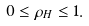<formula> <loc_0><loc_0><loc_500><loc_500>0 \leq \rho _ { H } \leq 1 .</formula> 